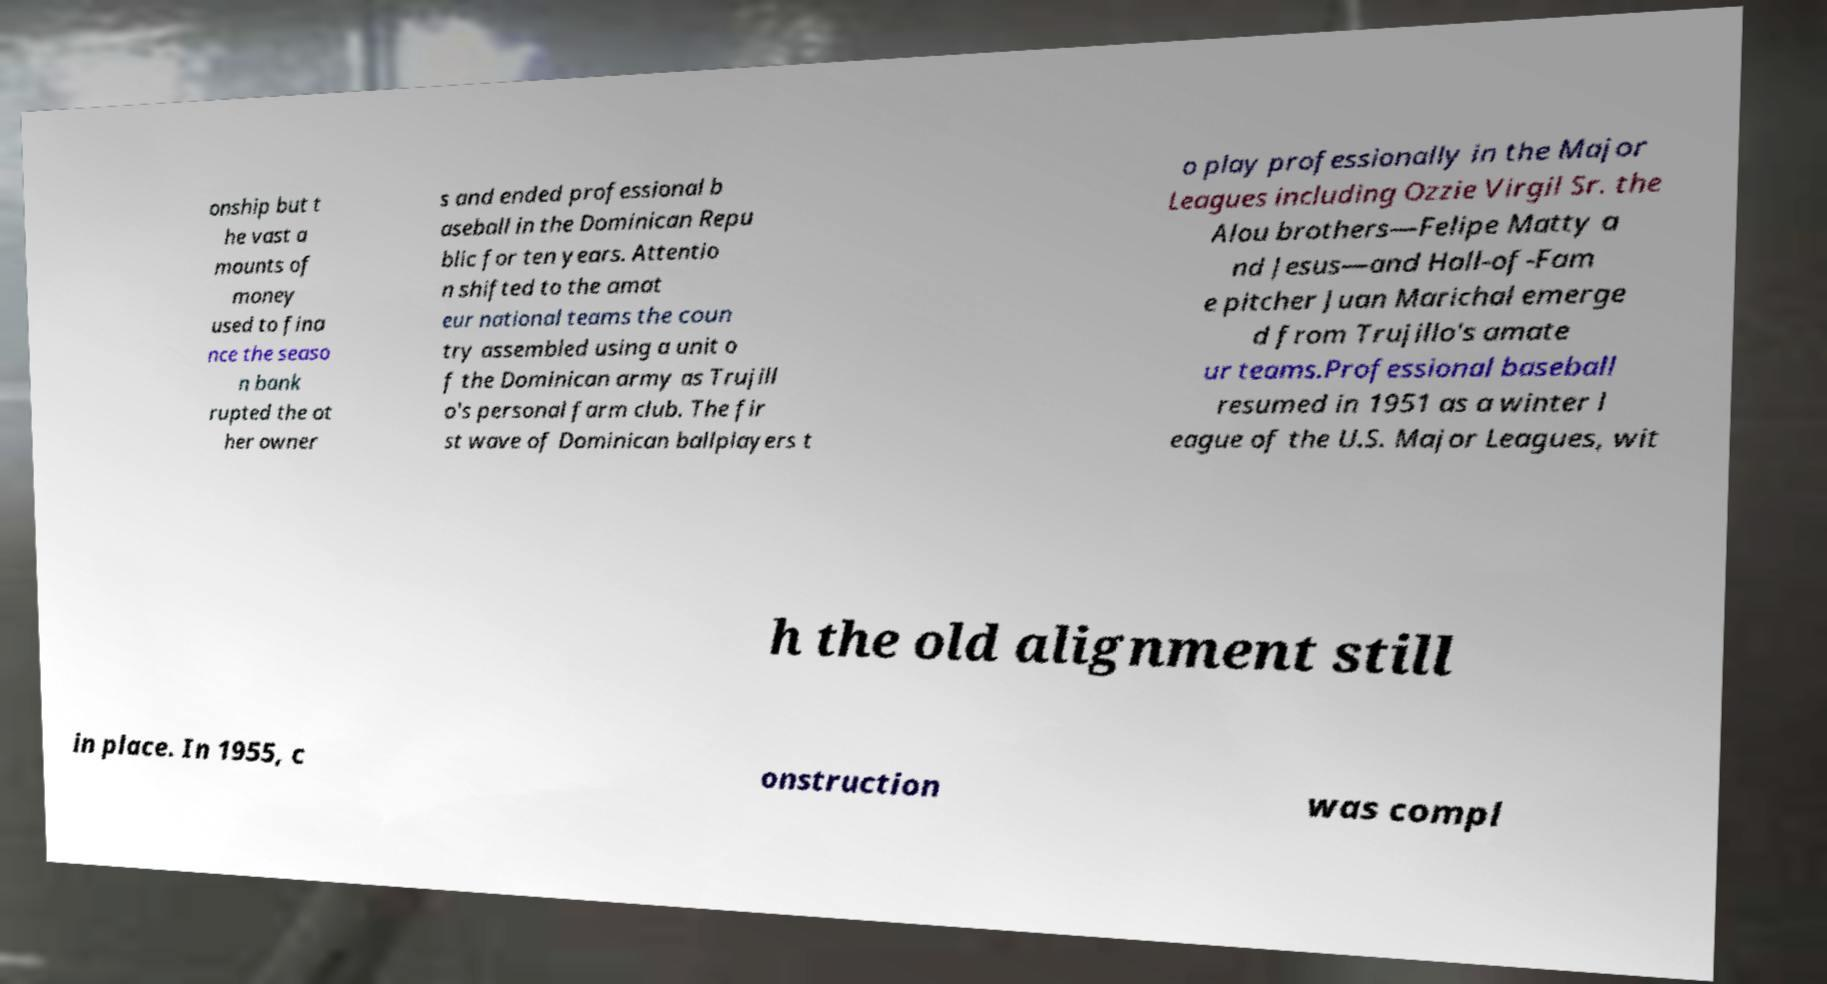There's text embedded in this image that I need extracted. Can you transcribe it verbatim? onship but t he vast a mounts of money used to fina nce the seaso n bank rupted the ot her owner s and ended professional b aseball in the Dominican Repu blic for ten years. Attentio n shifted to the amat eur national teams the coun try assembled using a unit o f the Dominican army as Trujill o's personal farm club. The fir st wave of Dominican ballplayers t o play professionally in the Major Leagues including Ozzie Virgil Sr. the Alou brothers—Felipe Matty a nd Jesus—and Hall-of-Fam e pitcher Juan Marichal emerge d from Trujillo's amate ur teams.Professional baseball resumed in 1951 as a winter l eague of the U.S. Major Leagues, wit h the old alignment still in place. In 1955, c onstruction was compl 